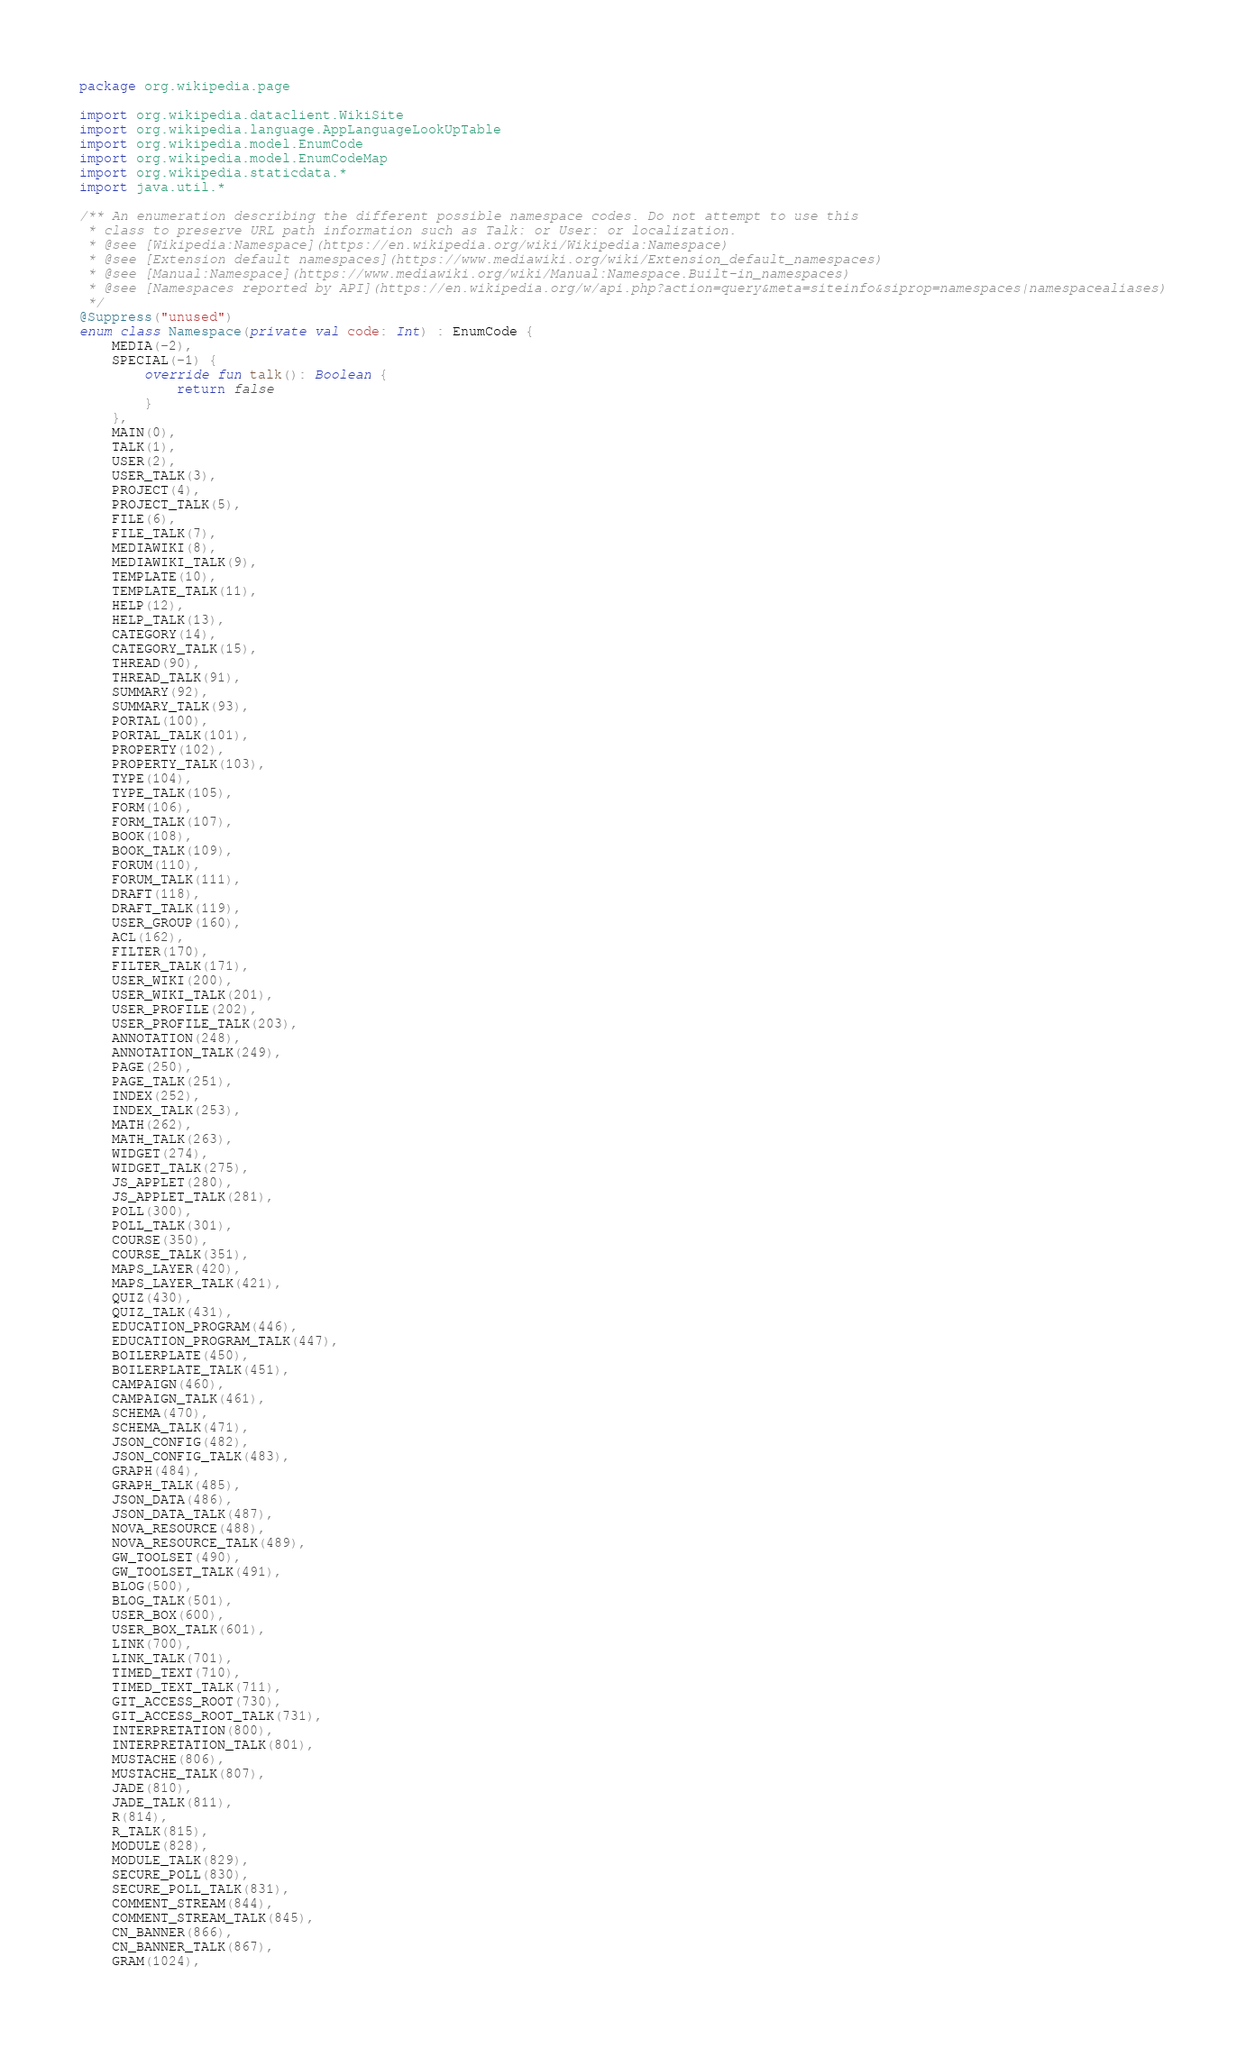Convert code to text. <code><loc_0><loc_0><loc_500><loc_500><_Kotlin_>package org.wikipedia.page

import org.wikipedia.dataclient.WikiSite
import org.wikipedia.language.AppLanguageLookUpTable
import org.wikipedia.model.EnumCode
import org.wikipedia.model.EnumCodeMap
import org.wikipedia.staticdata.*
import java.util.*

/** An enumeration describing the different possible namespace codes. Do not attempt to use this
 * class to preserve URL path information such as Talk: or User: or localization.
 * @see [Wikipedia:Namespace](https://en.wikipedia.org/wiki/Wikipedia:Namespace)
 * @see [Extension default namespaces](https://www.mediawiki.org/wiki/Extension_default_namespaces)
 * @see [Manual:Namespace](https://www.mediawiki.org/wiki/Manual:Namespace.Built-in_namespaces)
 * @see [Namespaces reported by API](https://en.wikipedia.org/w/api.php?action=query&meta=siteinfo&siprop=namespaces|namespacealiases)
 */
@Suppress("unused")
enum class Namespace(private val code: Int) : EnumCode {
    MEDIA(-2),
    SPECIAL(-1) {
        override fun talk(): Boolean {
            return false
        }
    },
    MAIN(0),
    TALK(1),
    USER(2),
    USER_TALK(3),
    PROJECT(4),
    PROJECT_TALK(5),
    FILE(6),
    FILE_TALK(7),
    MEDIAWIKI(8),
    MEDIAWIKI_TALK(9),
    TEMPLATE(10),
    TEMPLATE_TALK(11),
    HELP(12),
    HELP_TALK(13),
    CATEGORY(14),
    CATEGORY_TALK(15),
    THREAD(90),
    THREAD_TALK(91),
    SUMMARY(92),
    SUMMARY_TALK(93),
    PORTAL(100),
    PORTAL_TALK(101),
    PROPERTY(102),
    PROPERTY_TALK(103),
    TYPE(104),
    TYPE_TALK(105),
    FORM(106),
    FORM_TALK(107),
    BOOK(108),
    BOOK_TALK(109),
    FORUM(110),
    FORUM_TALK(111),
    DRAFT(118),
    DRAFT_TALK(119),
    USER_GROUP(160),
    ACL(162),
    FILTER(170),
    FILTER_TALK(171),
    USER_WIKI(200),
    USER_WIKI_TALK(201),
    USER_PROFILE(202),
    USER_PROFILE_TALK(203),
    ANNOTATION(248),
    ANNOTATION_TALK(249),
    PAGE(250),
    PAGE_TALK(251),
    INDEX(252),
    INDEX_TALK(253),
    MATH(262),
    MATH_TALK(263),
    WIDGET(274),
    WIDGET_TALK(275),
    JS_APPLET(280),
    JS_APPLET_TALK(281),
    POLL(300),
    POLL_TALK(301),
    COURSE(350),
    COURSE_TALK(351),
    MAPS_LAYER(420),
    MAPS_LAYER_TALK(421),
    QUIZ(430),
    QUIZ_TALK(431),
    EDUCATION_PROGRAM(446),
    EDUCATION_PROGRAM_TALK(447),
    BOILERPLATE(450),
    BOILERPLATE_TALK(451),
    CAMPAIGN(460),
    CAMPAIGN_TALK(461),
    SCHEMA(470),
    SCHEMA_TALK(471),
    JSON_CONFIG(482),
    JSON_CONFIG_TALK(483),
    GRAPH(484),
    GRAPH_TALK(485),
    JSON_DATA(486),
    JSON_DATA_TALK(487),
    NOVA_RESOURCE(488),
    NOVA_RESOURCE_TALK(489),
    GW_TOOLSET(490),
    GW_TOOLSET_TALK(491),
    BLOG(500),
    BLOG_TALK(501),
    USER_BOX(600),
    USER_BOX_TALK(601),
    LINK(700),
    LINK_TALK(701),
    TIMED_TEXT(710),
    TIMED_TEXT_TALK(711),
    GIT_ACCESS_ROOT(730),
    GIT_ACCESS_ROOT_TALK(731),
    INTERPRETATION(800),
    INTERPRETATION_TALK(801),
    MUSTACHE(806),
    MUSTACHE_TALK(807),
    JADE(810),
    JADE_TALK(811),
    R(814),
    R_TALK(815),
    MODULE(828),
    MODULE_TALK(829),
    SECURE_POLL(830),
    SECURE_POLL_TALK(831),
    COMMENT_STREAM(844),
    COMMENT_STREAM_TALK(845),
    CN_BANNER(866),
    CN_BANNER_TALK(867),
    GRAM(1024),</code> 